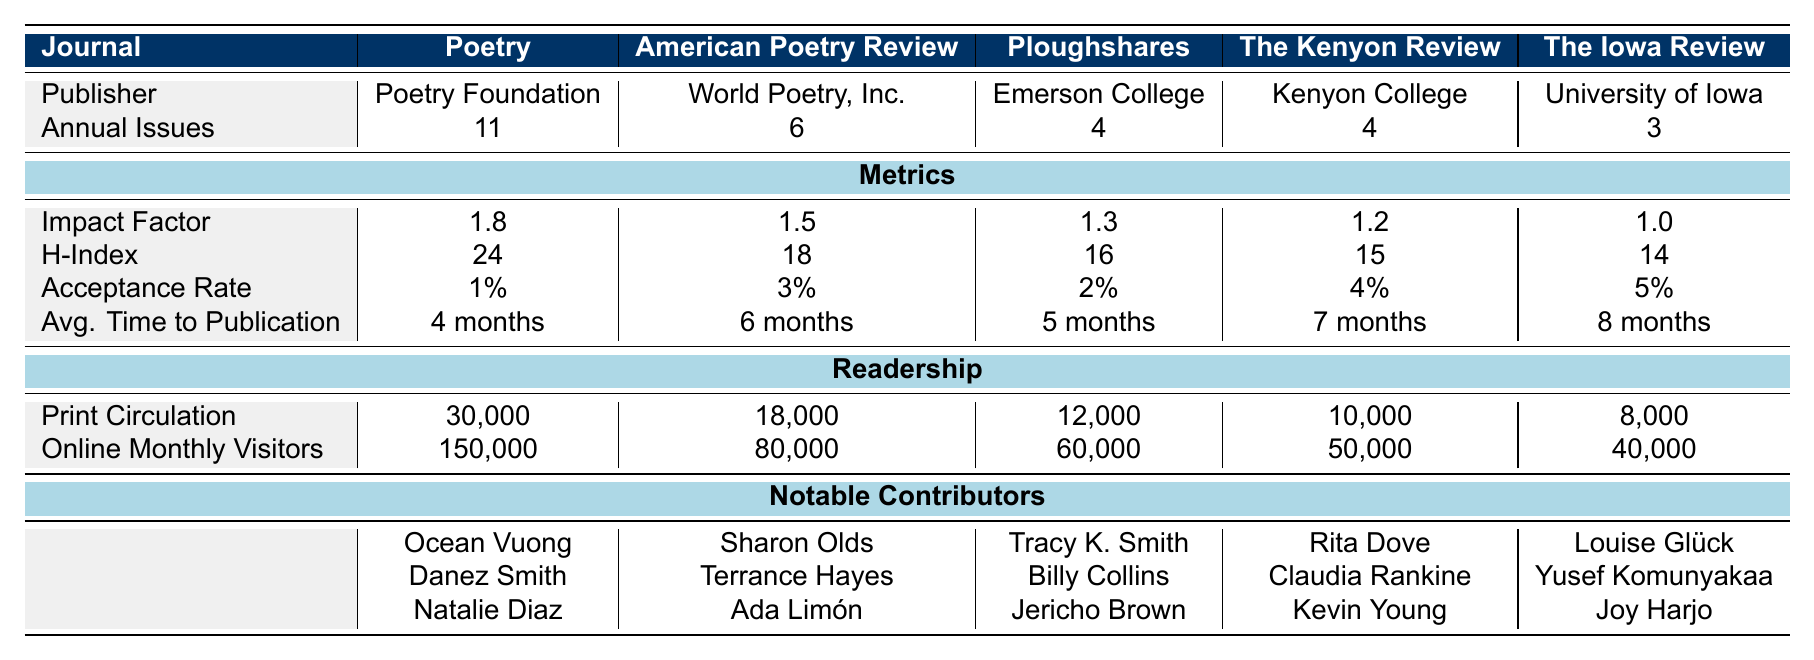What is the Impact Factor of "Poetry"? The table lists the Impact Factor for "Poetry" as 1.8.
Answer: 1.8 Which journal has the highest H-Index? According to the table, "Poetry" has the highest H-Index at 24.
Answer: Poetry What is the average time to publication for "The Kenyon Review"? The table specifies the average time to publication for "The Kenyon Review" is 7 months.
Answer: 7 months True or False: "American Poetry Review" has a lower print circulation than "Ploughshares." The table shows that "American Poetry Review" has a print circulation of 18,000, while "Ploughshares" has 12,000. Therefore, the statement is false.
Answer: False Calculate the total annual issues published across all listed journals. The annual issues for each journal are: Poetry (11), American Poetry Review (6), Ploughshares (4), The Kenyon Review (4), and The Iowa Review (3). Adding them gives: 11 + 6 + 4 + 4 + 3 = 28.
Answer: 28 Which journal has the lowest acceptance rate, and what is that rate? The table indicates that "Poetry" has an acceptance rate of 1%, which is the lowest among all journals listed.
Answer: Poetry, 1% How many online monthly visitors does "The Iowa Review" have compared to "Ploughshares"? "The Iowa Review" has 40,000 online monthly visitors, whereas "Ploughshares" has 60,000. The difference is 60,000 - 40,000 = 20,000, so "Ploughshares" has more by that amount.
Answer: Ploughshares has 20,000 more visitors What is the average acceptance rate for all journals listed? The acceptance rates are 1%, 3%, 2%, 4%, and 5%. To find the average, add them (1 + 3 + 2 + 4 + 5 = 15) and divide by 5 (15 / 5 = 3). Therefore, the average acceptance rate is 3%.
Answer: 3% Which notable contributor is shared by both "Ploughshares" and "The Kenyon Review"? The table reveals that there are no shared notable contributors between "Ploughshares" and "The Kenyon Review". Therefore, there isn't one.
Answer: None If we rank the journals by print circulation, which journal ranks second? The print circulations are: Poetry (30,000), American Poetry Review (18,000), Ploughshares (12,000), The Kenyon Review (10,000), and The Iowa Review (8,000). Therefore, the second highest is American Poetry Review at 18,000.
Answer: American Poetry Review 